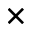<formula> <loc_0><loc_0><loc_500><loc_500>\times</formula> 